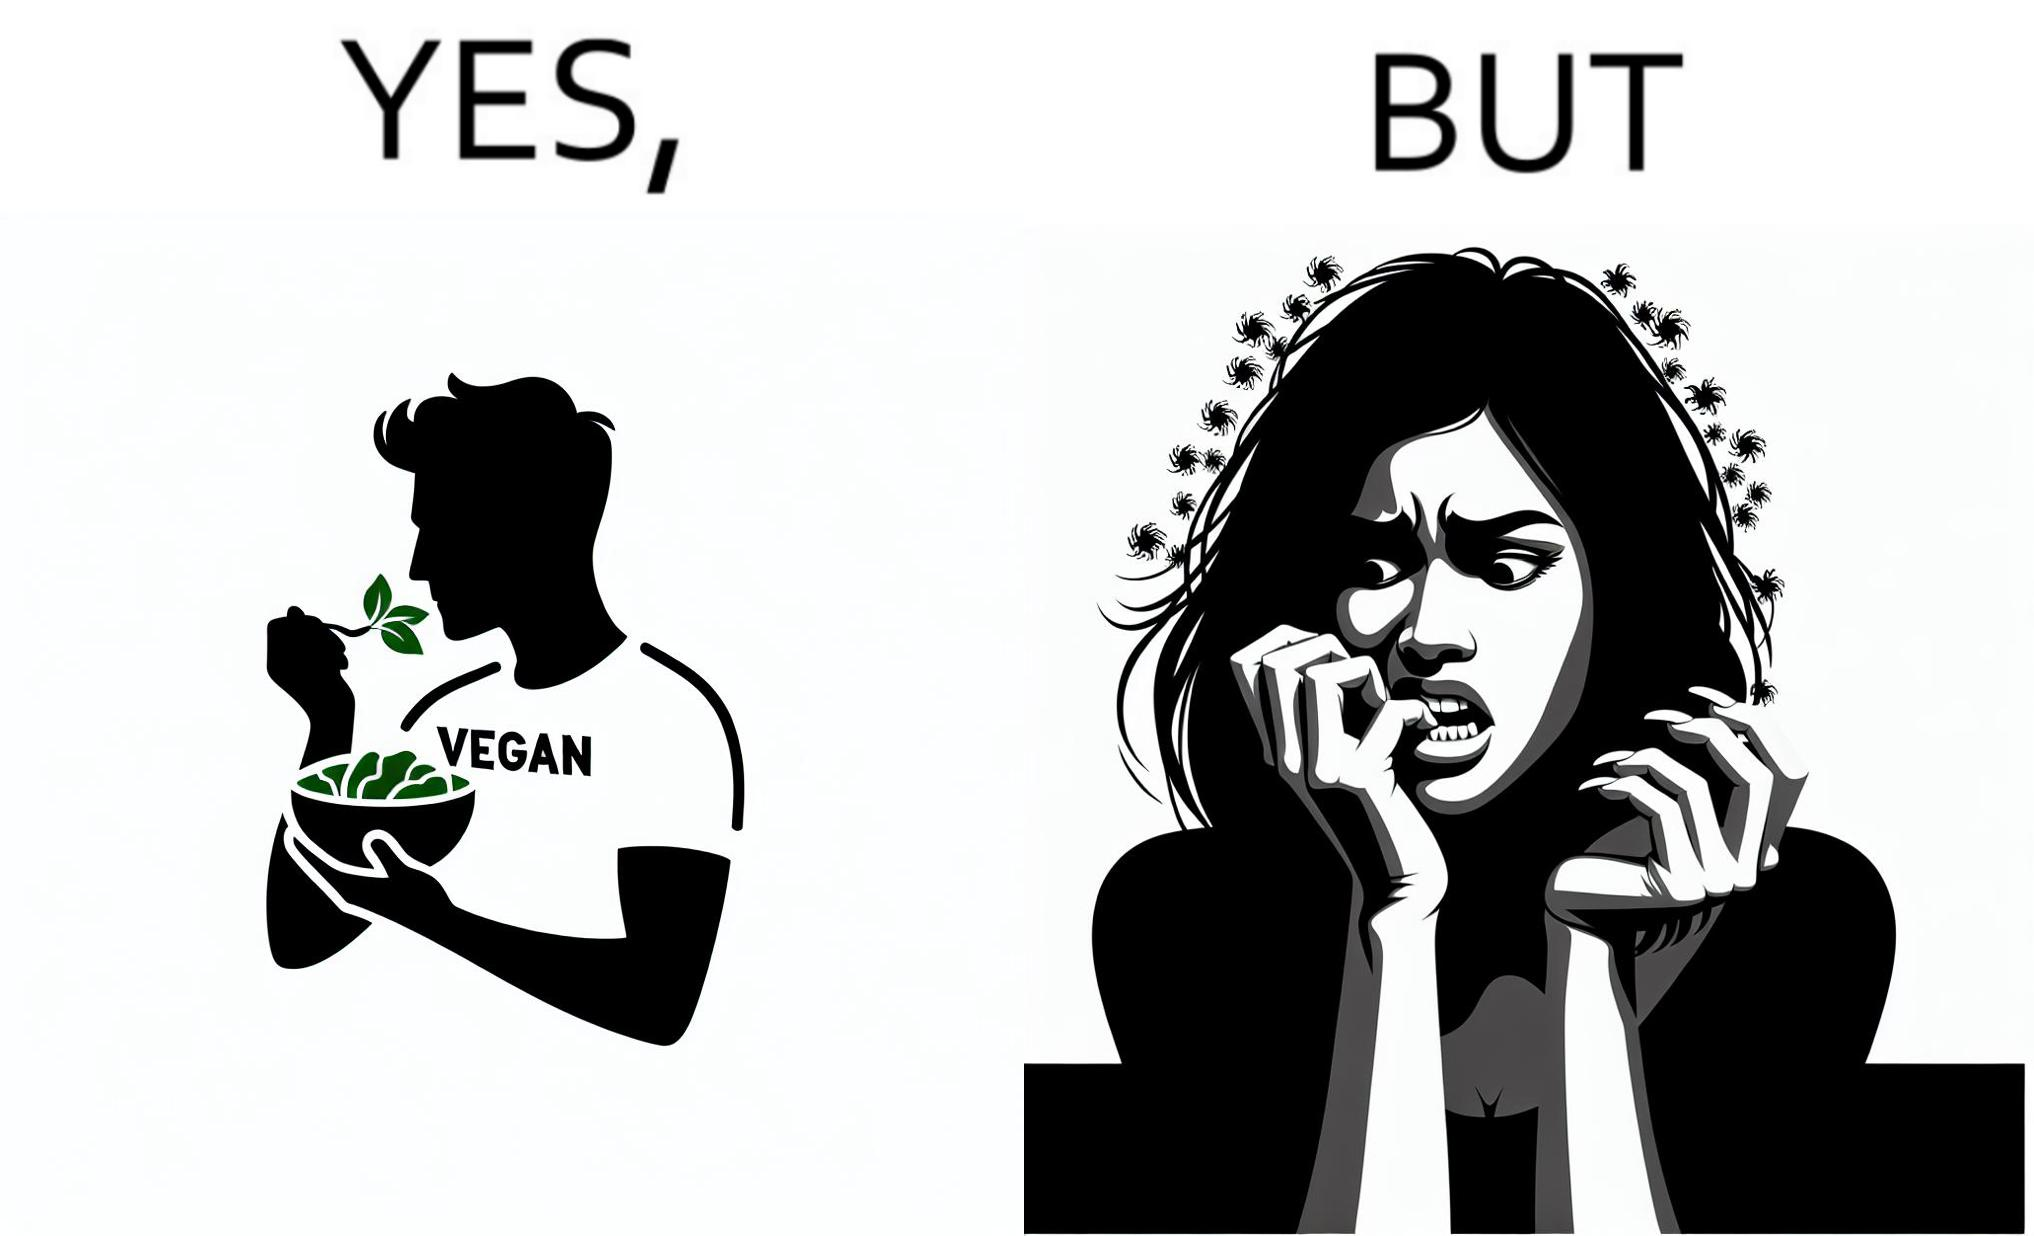Describe what you see in this image. The image is funny because while the man claims to be vegan, he is biting skin off his own hand. 